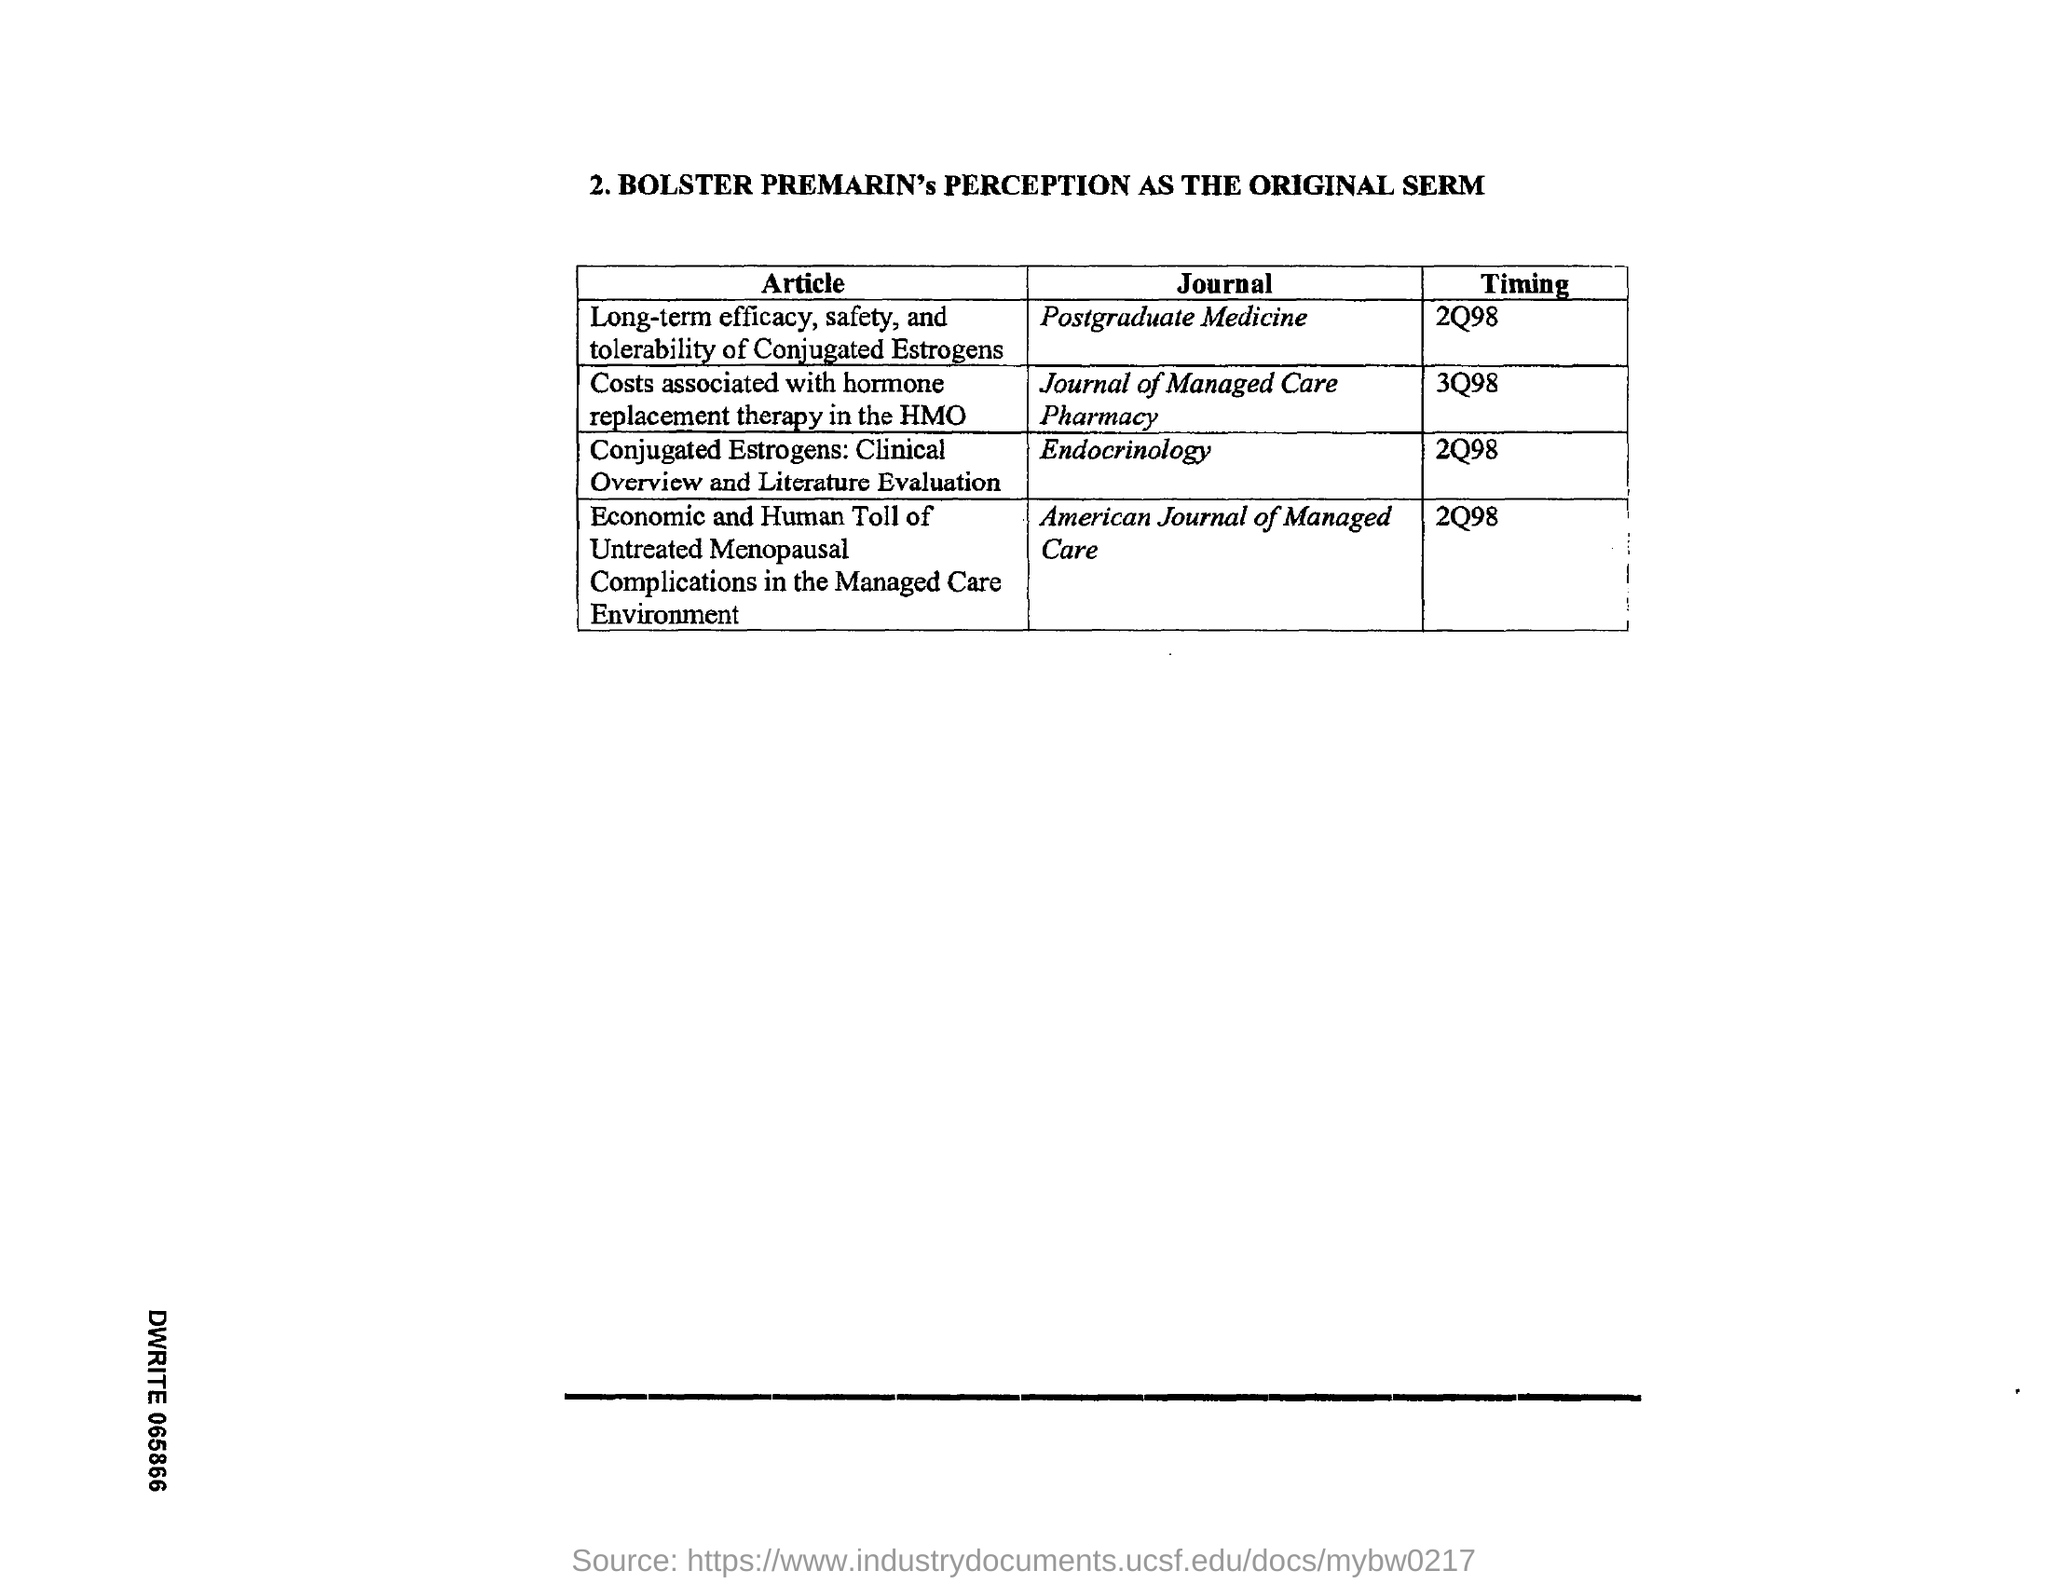Point out several critical features in this image. The timing for the journal "American Journal of Managed Care" was in the second quarter of 1998. The timing for the journal "Postgraduate Medicine" is 2Q98. The timing for the journal "Endocrinology" was in the second quarter of 1998. The timing for the journal "Journal of Managed Care Pharmacy" was from 3Q98. 